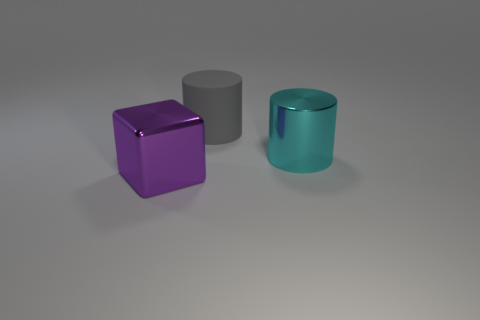Subtract all green cylinders. Subtract all gray spheres. How many cylinders are left? 2 Subtract all yellow cylinders. How many brown blocks are left? 0 Add 2 cyans. How many big purples exist? 0 Subtract all large cyan matte blocks. Subtract all large cylinders. How many objects are left? 1 Add 2 large purple things. How many large purple things are left? 3 Add 1 cyan cylinders. How many cyan cylinders exist? 2 Add 3 big gray metal blocks. How many objects exist? 6 Subtract all cyan cylinders. How many cylinders are left? 1 Subtract 0 gray blocks. How many objects are left? 3 Subtract all cylinders. How many objects are left? 1 